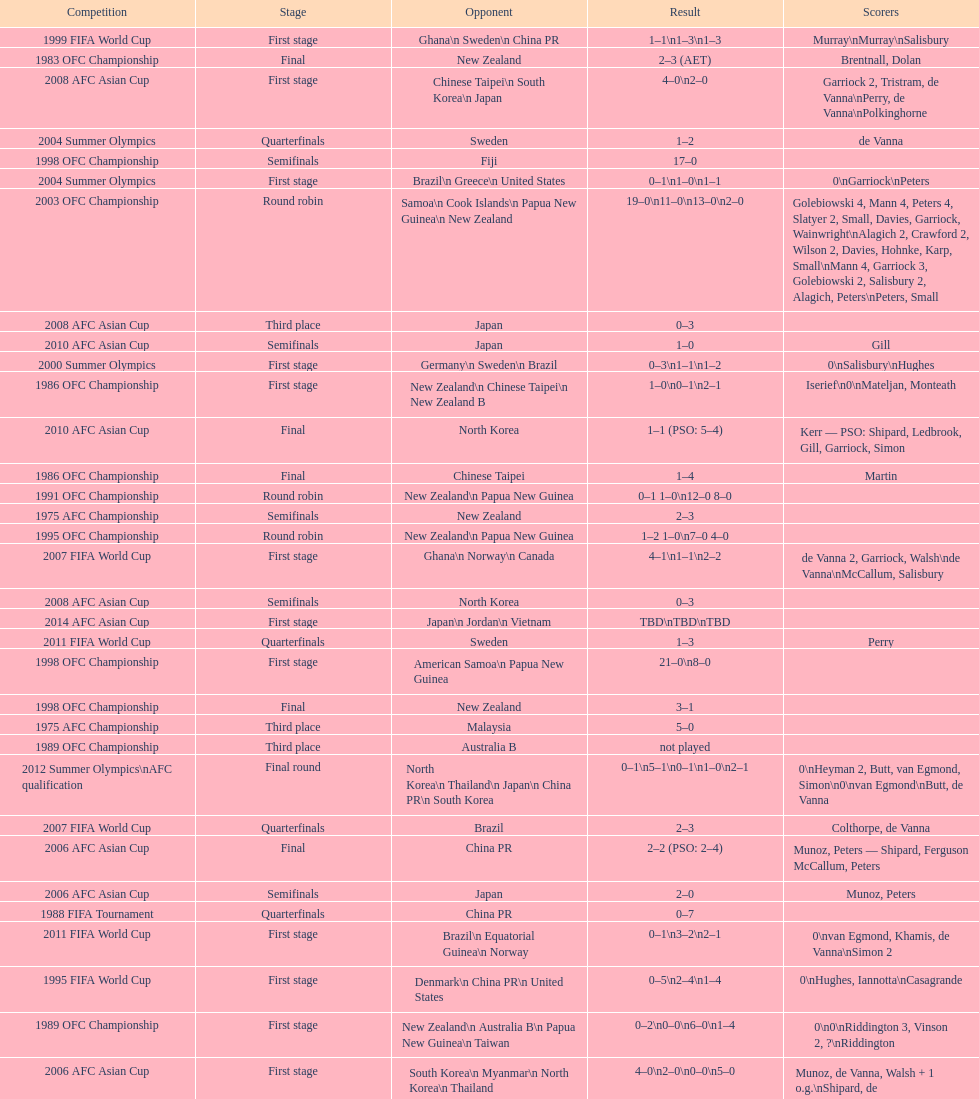What it the total number of countries in the first stage of the 2008 afc asian cup? 4. 